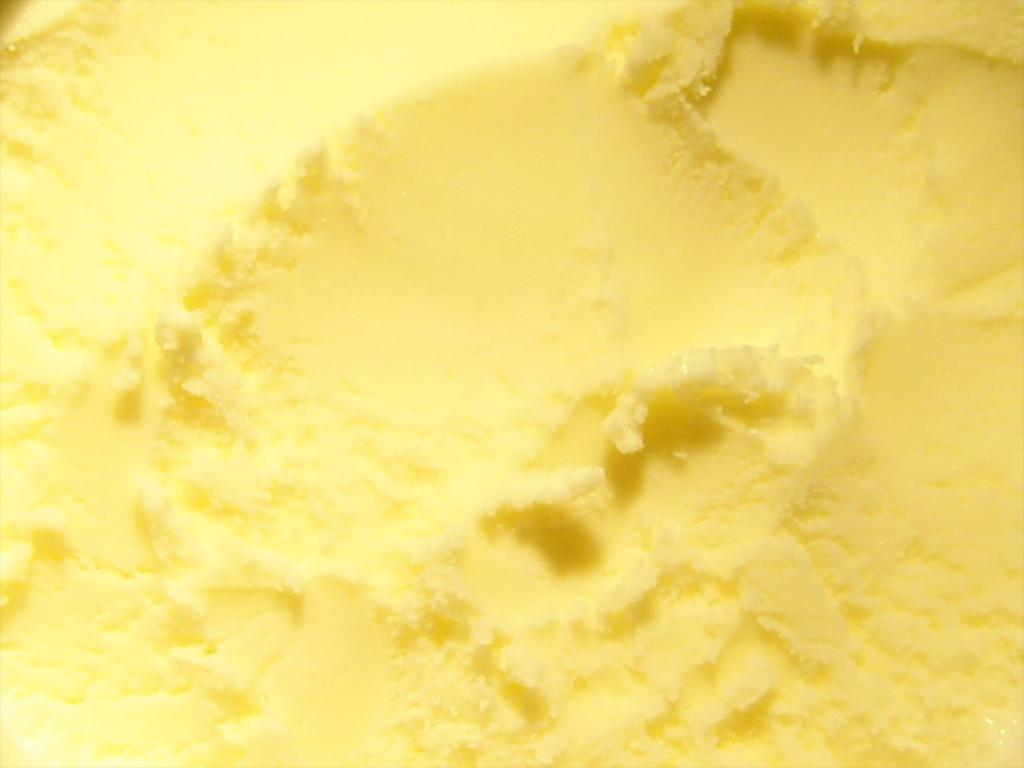What type of insect can be seen reading a fictional book in the image? There is no insect or book present in the image, as no facts were provided about the image. 